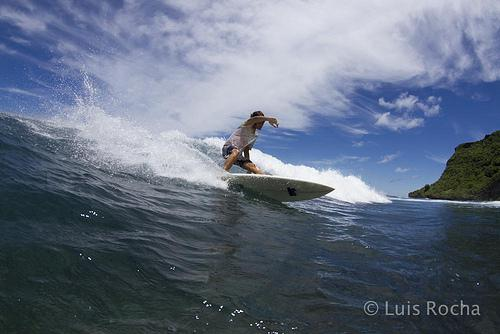Question: why is the person on a surfboard?
Choices:
A. Waiting for a wave.
B. They are surfing.
C. Learning to surf.
D. Resting.
Answer with the letter. Answer: B Question: who is in the picture?
Choices:
A. The surfer.
B. The dog trainer.
C. The teacher.
D. The preacher.
Answer with the letter. Answer: A 